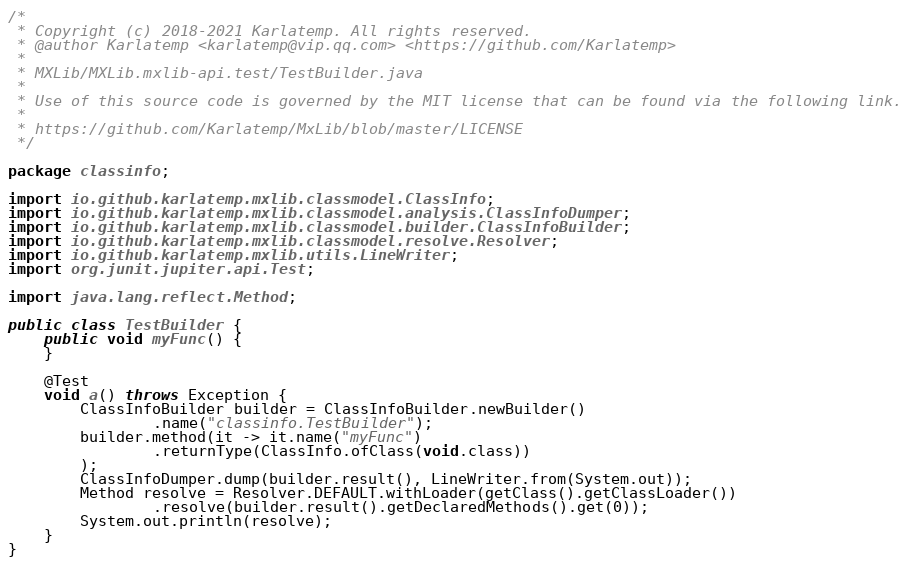Convert code to text. <code><loc_0><loc_0><loc_500><loc_500><_Java_>/*
 * Copyright (c) 2018-2021 Karlatemp. All rights reserved.
 * @author Karlatemp <karlatemp@vip.qq.com> <https://github.com/Karlatemp>
 *
 * MXLib/MXLib.mxlib-api.test/TestBuilder.java
 *
 * Use of this source code is governed by the MIT license that can be found via the following link.
 *
 * https://github.com/Karlatemp/MxLib/blob/master/LICENSE
 */

package classinfo;

import io.github.karlatemp.mxlib.classmodel.ClassInfo;
import io.github.karlatemp.mxlib.classmodel.analysis.ClassInfoDumper;
import io.github.karlatemp.mxlib.classmodel.builder.ClassInfoBuilder;
import io.github.karlatemp.mxlib.classmodel.resolve.Resolver;
import io.github.karlatemp.mxlib.utils.LineWriter;
import org.junit.jupiter.api.Test;

import java.lang.reflect.Method;

public class TestBuilder {
    public void myFunc() {
    }

    @Test
    void a() throws Exception {
        ClassInfoBuilder builder = ClassInfoBuilder.newBuilder()
                .name("classinfo.TestBuilder");
        builder.method(it -> it.name("myFunc")
                .returnType(ClassInfo.ofClass(void.class))
        );
        ClassInfoDumper.dump(builder.result(), LineWriter.from(System.out));
        Method resolve = Resolver.DEFAULT.withLoader(getClass().getClassLoader())
                .resolve(builder.result().getDeclaredMethods().get(0));
        System.out.println(resolve);
    }
}
</code> 